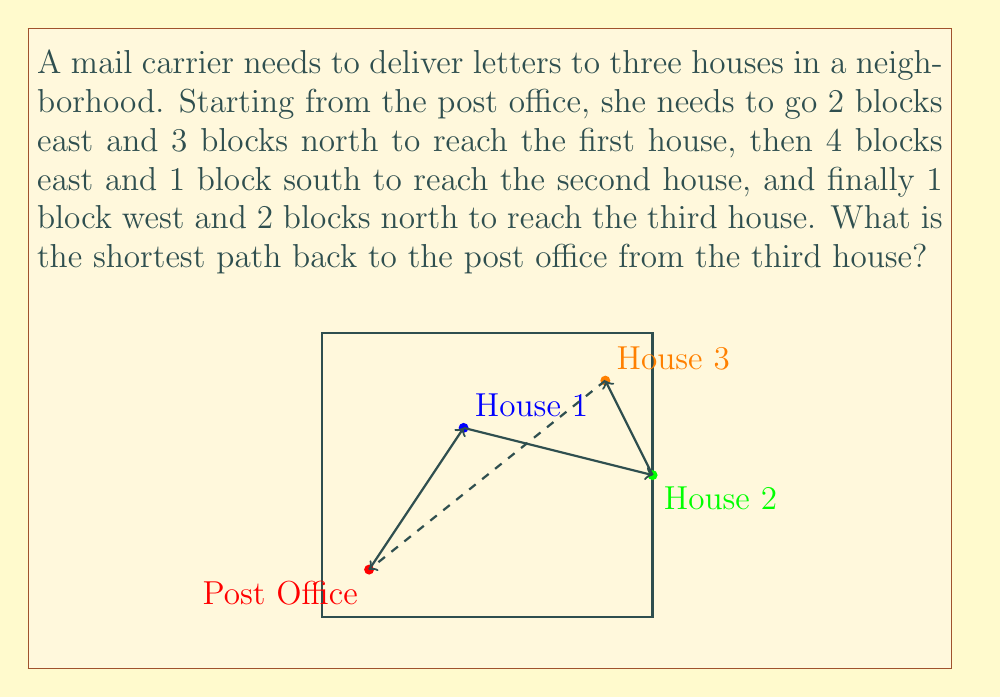Provide a solution to this math problem. Let's approach this step-by-step using vector addition:

1) First, let's represent each movement as a vector:
   Post Office to House 1: $\vec{v_1} = \langle 2, 3 \rangle$
   House 1 to House 2: $\vec{v_2} = \langle 4, -1 \rangle$
   House 2 to House 3: $\vec{v_3} = \langle -1, 2 \rangle$

2) The total displacement from the post office to House 3 is the sum of these vectors:
   $\vec{v_{total}} = \vec{v_1} + \vec{v_2} + \vec{v_3}$

3) Let's add these vectors:
   $\vec{v_{total}} = \langle 2, 3 \rangle + \langle 4, -1 \rangle + \langle -1, 2 \rangle$
   $\vec{v_{total}} = \langle 2+4-1, 3-1+2 \rangle$
   $\vec{v_{total}} = \langle 5, 4 \rangle$

4) This vector $\langle 5, 4 \rangle$ represents the displacement from the post office to House 3.

5) The shortest path back to the post office would be the negative of this vector:
   $\vec{v_{return}} = -\vec{v_{total}} = \langle -5, -4 \rangle$

6) This means the mail carrier needs to go 5 blocks west and 4 blocks south to return to the post office by the shortest path.

7) The magnitude of this vector (the actual distance) can be calculated using the Pythagorean theorem:
   $|\vec{v_{return}}| = \sqrt{(-5)^2 + (-4)^2} = \sqrt{25 + 16} = \sqrt{41} \approx 6.40$ blocks
Answer: $\langle -5, -4 \rangle$ or 5 blocks west and 4 blocks south 